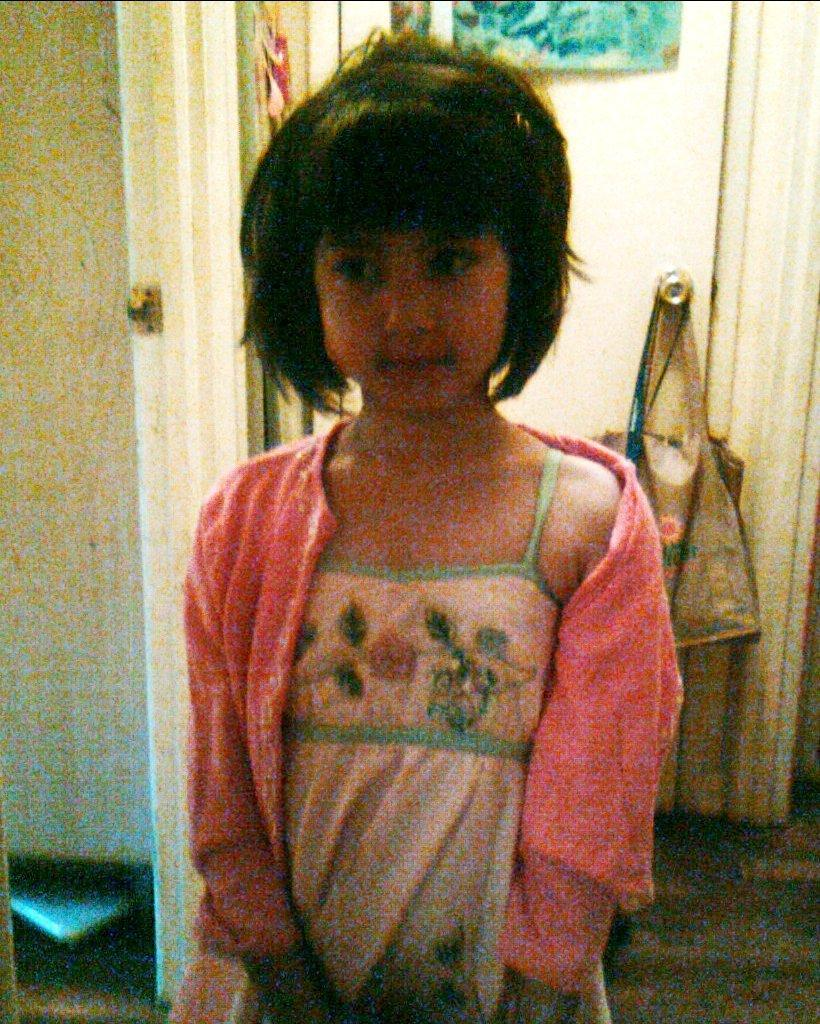Who is present in the image? There is a girl in the image. What architectural feature can be seen in the image? There is a door and a wall in the image. What object is the girl holding? There is a bag in the image. Can you describe the unspecified "things" in the image? Unfortunately, the facts provided do not give any details about the "things" in the image. What type of cake is being served on the street in the image? There is no cake or street present in the image. 